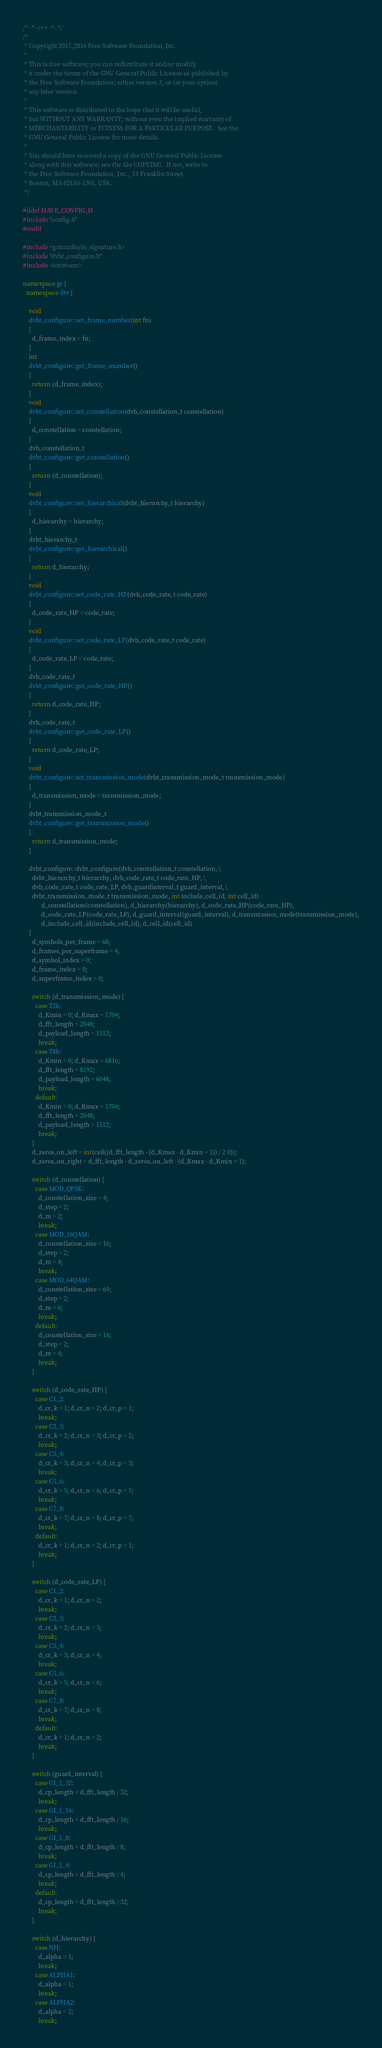Convert code to text. <code><loc_0><loc_0><loc_500><loc_500><_C++_>/* -*- c++ -*- */
/* 
 * Copyright 2015,2016 Free Software Foundation, Inc.
 * 
 * This is free software; you can redistribute it and/or modify
 * it under the terms of the GNU General Public License as published by
 * the Free Software Foundation; either version 3, or (at your option)
 * any later version.
 * 
 * This software is distributed in the hope that it will be useful,
 * but WITHOUT ANY WARRANTY; without even the implied warranty of
 * MERCHANTABILITY or FITNESS FOR A PARTICULAR PURPOSE.  See the
 * GNU General Public License for more details.
 * 
 * You should have received a copy of the GNU General Public License
 * along with this software; see the file COPYING.  If not, write to
 * the Free Software Foundation, Inc., 51 Franklin Street,
 * Boston, MA 02110-1301, USA.
 */

#ifdef HAVE_CONFIG_H
#include "config.h"
#endif

#include <gnuradio/io_signature.h>
#include "dvbt_configure.h"
#include <iostream>

namespace gr {
  namespace dtv {

    void
    dvbt_configure::set_frame_number(int fn)
    {
      d_frame_index = fn;
    }
    int
    dvbt_configure::get_frame_mumber()
    {
      return (d_frame_index);
    }
    void
    dvbt_configure::set_constellation(dvb_constellation_t constellation)
    {
      d_constellation = constellation;
    }
    dvb_constellation_t
    dvbt_configure::get_constellation()
    {
      return (d_constellation);
    }
    void
    dvbt_configure::set_hierarchical(dvbt_hierarchy_t hierarchy)
    {
      d_hierarchy = hierarchy;
    }
    dvbt_hierarchy_t
    dvbt_configure::get_hierarchical()
    {
      return d_hierarchy;
    }
    void
    dvbt_configure::set_code_rate_HP(dvb_code_rate_t code_rate)
    {
      d_code_rate_HP = code_rate;
    }
    void
    dvbt_configure::set_code_rate_LP(dvb_code_rate_t code_rate)
    {
      d_code_rate_LP = code_rate;
    }
    dvb_code_rate_t
    dvbt_configure::get_code_rate_HP()
    {
      return d_code_rate_HP;
    }
    dvb_code_rate_t
    dvbt_configure::get_code_rate_LP()
    {
      return d_code_rate_LP;
    }
    void
    dvbt_configure::set_transmission_mode(dvbt_transmission_mode_t transmission_mode)
    {
      d_transmission_mode = transmission_mode;
    }
    dvbt_transmission_mode_t
    dvbt_configure::get_transmission_mode()
    {
      return d_transmission_mode;
    }

    dvbt_configure::dvbt_configure(dvb_constellation_t constellation, \
      dvbt_hierarchy_t hierarchy, dvb_code_rate_t code_rate_HP, \
      dvb_code_rate_t code_rate_LP, dvb_guardinterval_t guard_interval, \
      dvbt_transmission_mode_t transmission_mode, int include_cell_id, int cell_id) :
            d_constellation(constellation), d_hierarchy(hierarchy), d_code_rate_HP(code_rate_HP),
            d_code_rate_LP(code_rate_LP), d_guard_interval(guard_interval), d_transmission_mode(transmission_mode),
            d_include_cell_id(include_cell_id), d_cell_id(cell_id)
    {
      d_symbols_per_frame = 68;
      d_frames_per_superframe = 4;
      d_symbol_index = 0;
      d_frame_index = 0;
      d_superframe_index = 0;

      switch (d_transmission_mode) {
        case T2k:
          d_Kmin = 0; d_Kmax = 1704;
          d_fft_length = 2048;
          d_payload_length = 1512;
          break;
        case T8k:
          d_Kmin = 0; d_Kmax = 6816;
          d_fft_length = 8192;
          d_payload_length = 6048;
          break;
        default:
          d_Kmin = 0; d_Kmax = 1704;
          d_fft_length = 2048;
          d_payload_length = 1512;
          break;
      }
      d_zeros_on_left = int(ceil((d_fft_length - (d_Kmax - d_Kmin + 1)) / 2.0));
      d_zeros_on_right = d_fft_length - d_zeros_on_left - (d_Kmax - d_Kmin + 1);

      switch (d_constellation) {
        case MOD_QPSK:
          d_constellation_size = 4;
          d_step = 2;
          d_m = 2;
          break;
        case MOD_16QAM:
          d_constellation_size = 16;
          d_step = 2;
          d_m = 4;
          break;
        case MOD_64QAM:
          d_constellation_size = 64;
          d_step = 2;
          d_m = 6;
          break;
        default:
          d_constellation_size = 16;
          d_step = 2;
          d_m = 4;
          break;
      }

      switch (d_code_rate_HP) {
        case C1_2:
          d_cr_k = 1; d_cr_n = 2; d_cr_p = 1;
          break;
        case C2_3:
          d_cr_k = 2; d_cr_n = 3; d_cr_p = 2;
          break;
        case C3_4:
          d_cr_k = 3; d_cr_n = 4; d_cr_p = 3;
          break;
        case C5_6:
          d_cr_k = 5; d_cr_n = 6; d_cr_p = 5;
          break;
        case C7_8:
          d_cr_k = 7; d_cr_n = 8; d_cr_p = 7;
          break;
        default:
          d_cr_k = 1; d_cr_n = 2; d_cr_p = 1;
          break;
      }

      switch (d_code_rate_LP) {
        case C1_2:
          d_cr_k = 1; d_cr_n = 2;
          break;
        case C2_3:
          d_cr_k = 2; d_cr_n = 3;
          break;
        case C3_4:
          d_cr_k = 3; d_cr_n = 4;
          break;
        case C5_6:
          d_cr_k = 5; d_cr_n = 6;
          break;
        case C7_8:
          d_cr_k = 7; d_cr_n = 8;
          break;
        default:
          d_cr_k = 1; d_cr_n = 2;
          break;
      }

      switch (guard_interval) {
        case GI_1_32:
          d_cp_length = d_fft_length / 32;
          break;
        case GI_1_16:
          d_cp_length = d_fft_length / 16;
          break;
        case GI_1_8:
          d_cp_length = d_fft_length / 8;
          break;
        case GI_1_4:
          d_cp_length = d_fft_length / 4;
          break;
        default:
          d_cp_length = d_fft_length / 32;
          break;
      }

      switch (d_hierarchy) {
        case NH:
          d_alpha = 1;
          break;
        case ALPHA1:
          d_alpha = 1;
          break;
        case ALPHA2:
          d_alpha = 2;
          break;</code> 